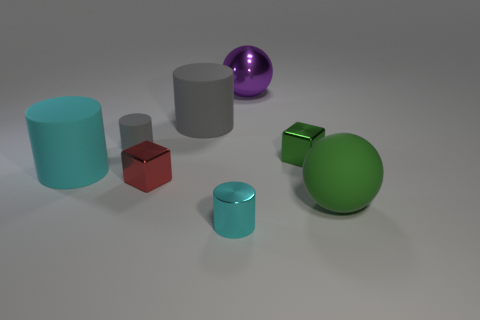Do the ball that is behind the small green block and the tiny cyan object have the same material? The ball appears to have a matte finish and a uniform color distribution, while the tiny cyan object has a reflective surface with some subtle color gradients, suggesting differences in material properties. Therefore, despite their appearances in the image, it's unlikely that they are made of the same material. 